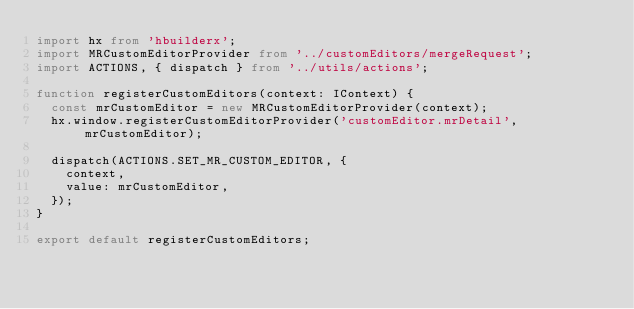Convert code to text. <code><loc_0><loc_0><loc_500><loc_500><_TypeScript_>import hx from 'hbuilderx';
import MRCustomEditorProvider from '../customEditors/mergeRequest';
import ACTIONS, { dispatch } from '../utils/actions';

function registerCustomEditors(context: IContext) {
  const mrCustomEditor = new MRCustomEditorProvider(context);
  hx.window.registerCustomEditorProvider('customEditor.mrDetail', mrCustomEditor);

  dispatch(ACTIONS.SET_MR_CUSTOM_EDITOR, {
    context,
    value: mrCustomEditor,
  });
}

export default registerCustomEditors;
</code> 